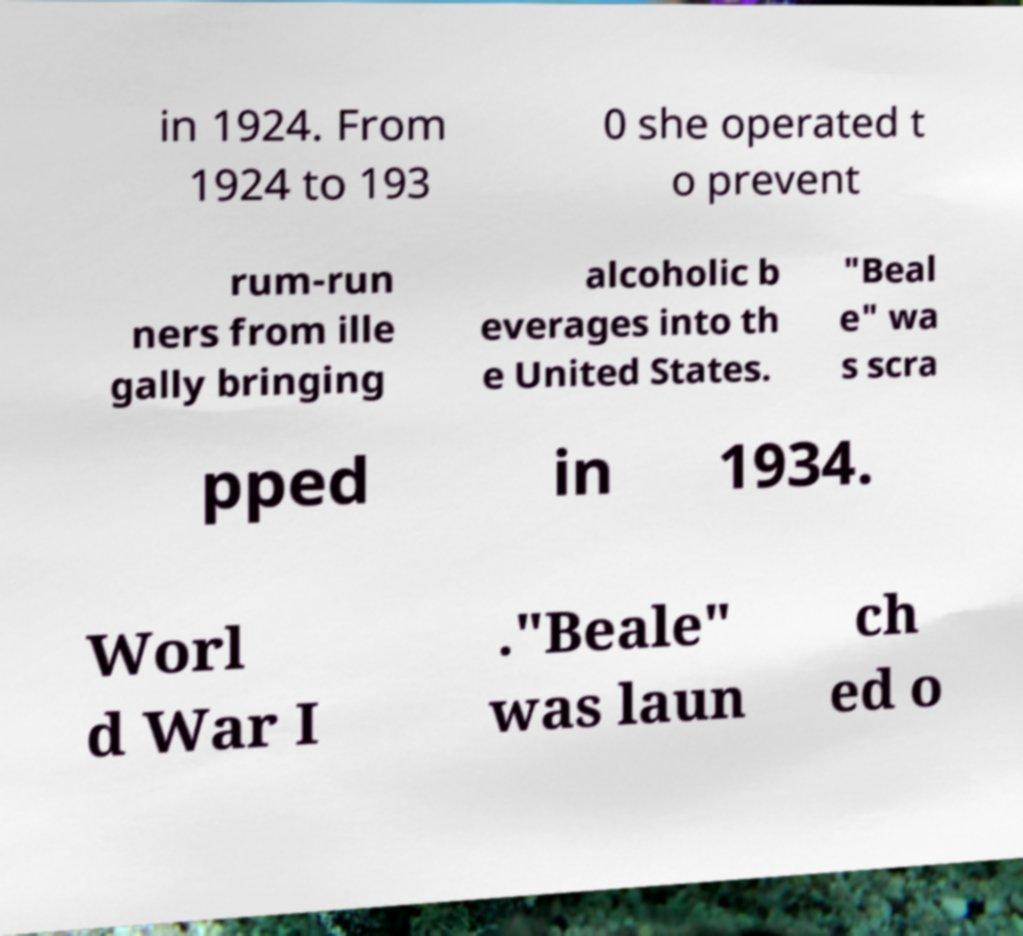I need the written content from this picture converted into text. Can you do that? in 1924. From 1924 to 193 0 she operated t o prevent rum-run ners from ille gally bringing alcoholic b everages into th e United States. "Beal e" wa s scra pped in 1934. Worl d War I ."Beale" was laun ch ed o 